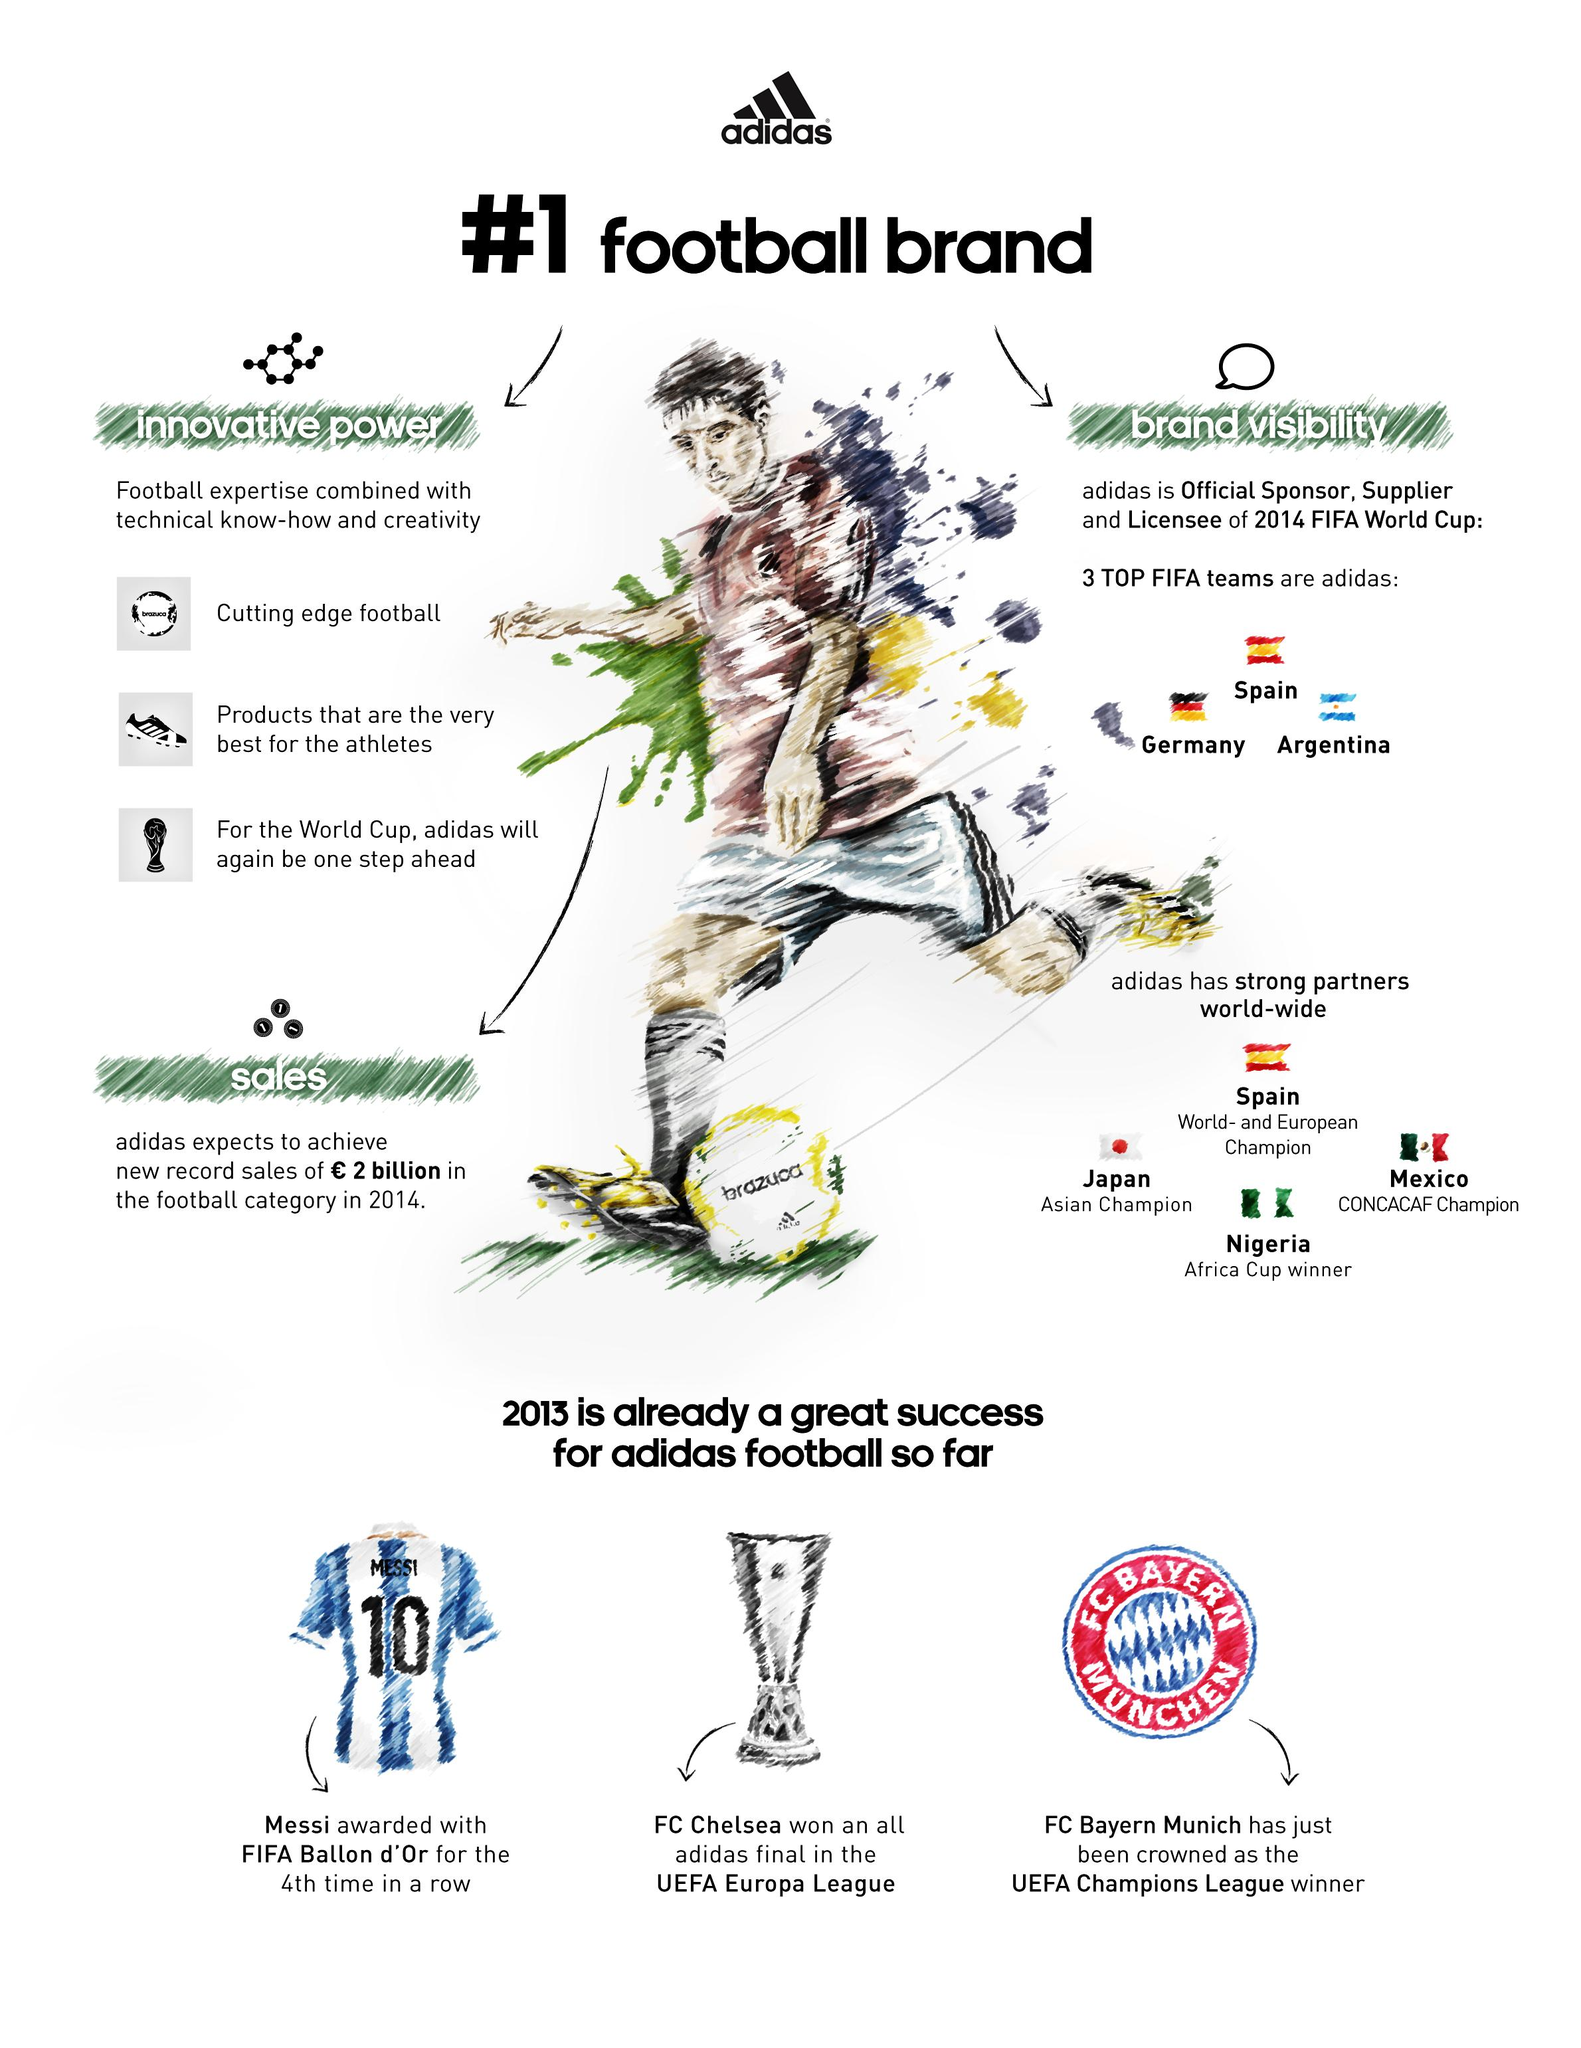Mention a couple of crucial points in this snapshot. The top three FIFA teams are Spain, Germany, and Argentina. Adidas expected to generate approximately 2 billion Euros in sales in 2014. It is known that Spain is the world and European champion. In 2013, Lionel Messi received the FIFA Ballon d'Or award for the fourth consecutive time. In the year 2013, FC Bayern Munich was crowned as the UEFA Champions League winner. 